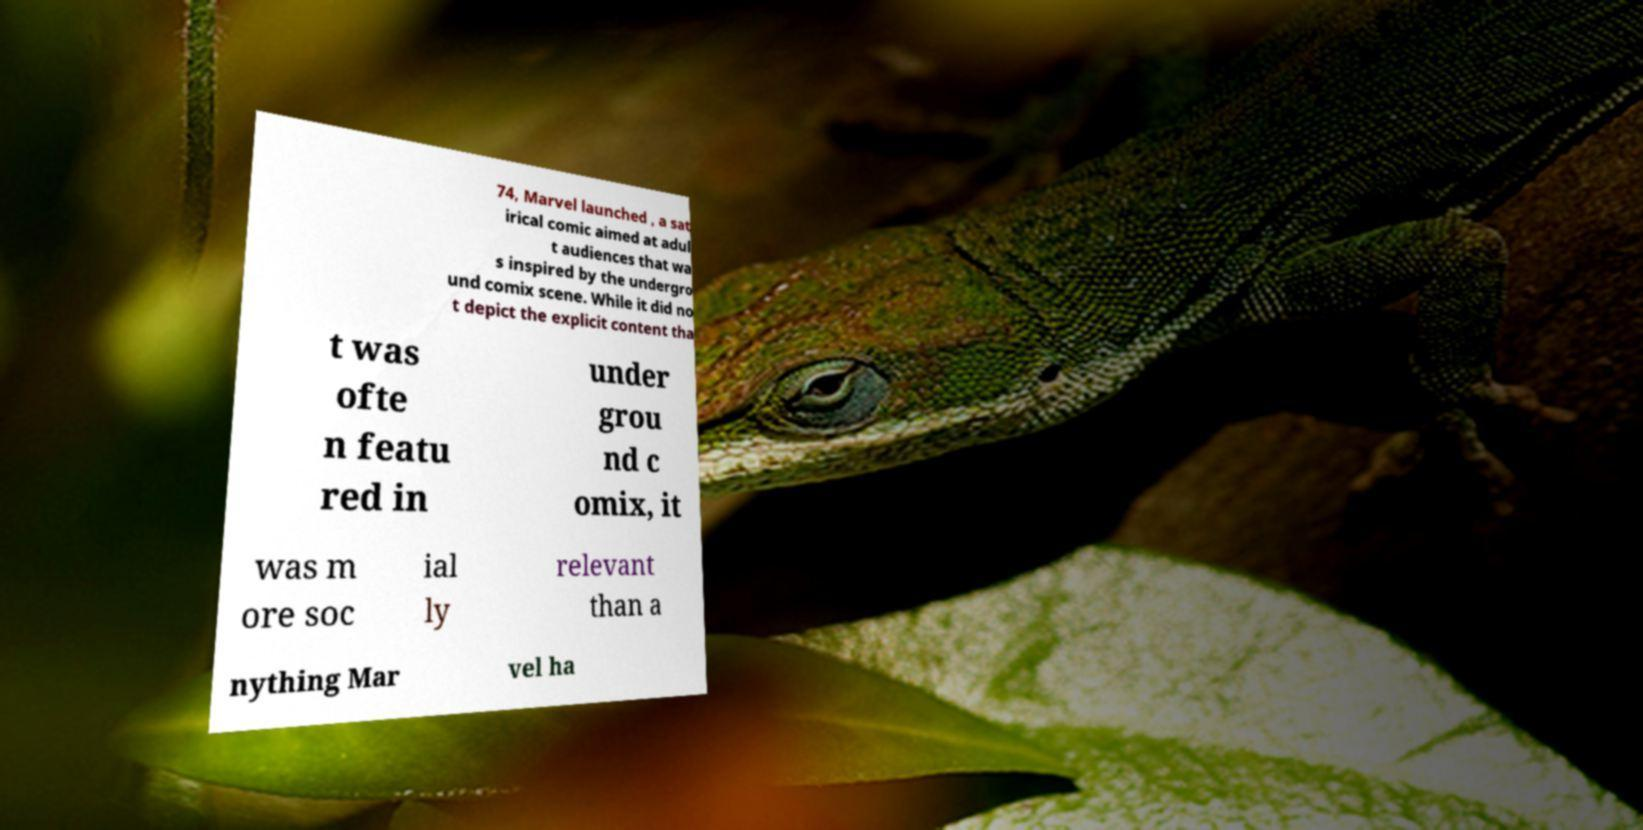Could you assist in decoding the text presented in this image and type it out clearly? 74, Marvel launched , a sat irical comic aimed at adul t audiences that wa s inspired by the undergro und comix scene. While it did no t depict the explicit content tha t was ofte n featu red in under grou nd c omix, it was m ore soc ial ly relevant than a nything Mar vel ha 